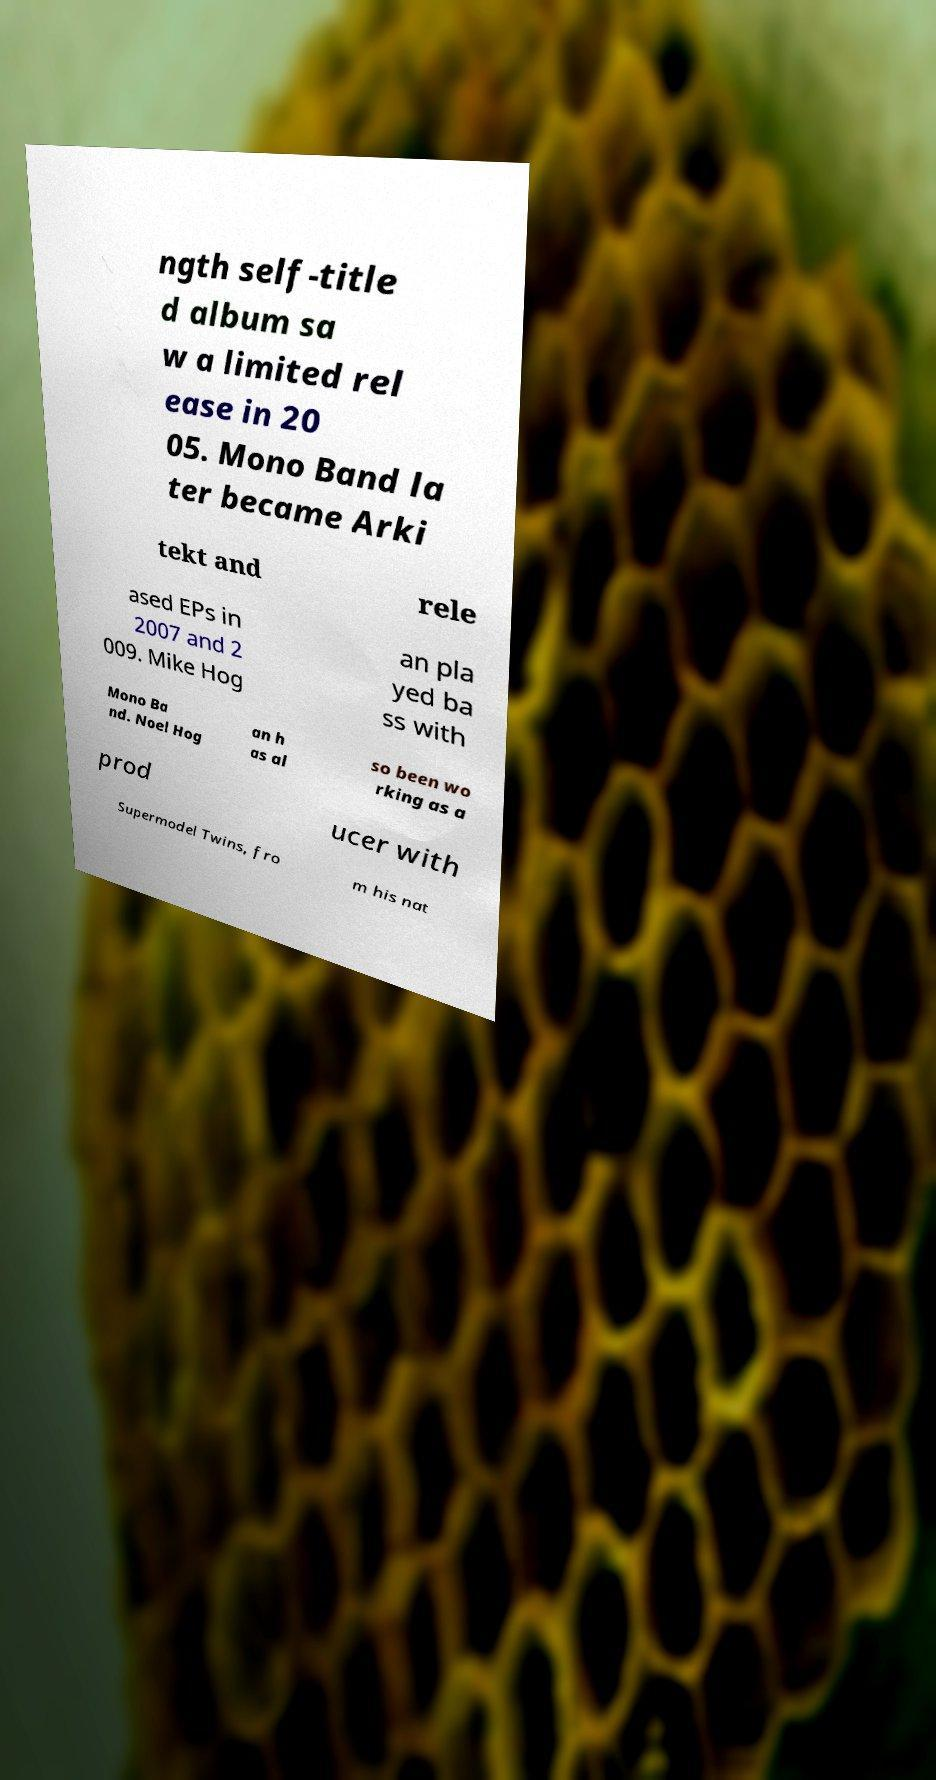Please identify and transcribe the text found in this image. ngth self-title d album sa w a limited rel ease in 20 05. Mono Band la ter became Arki tekt and rele ased EPs in 2007 and 2 009. Mike Hog an pla yed ba ss with Mono Ba nd. Noel Hog an h as al so been wo rking as a prod ucer with Supermodel Twins, fro m his nat 